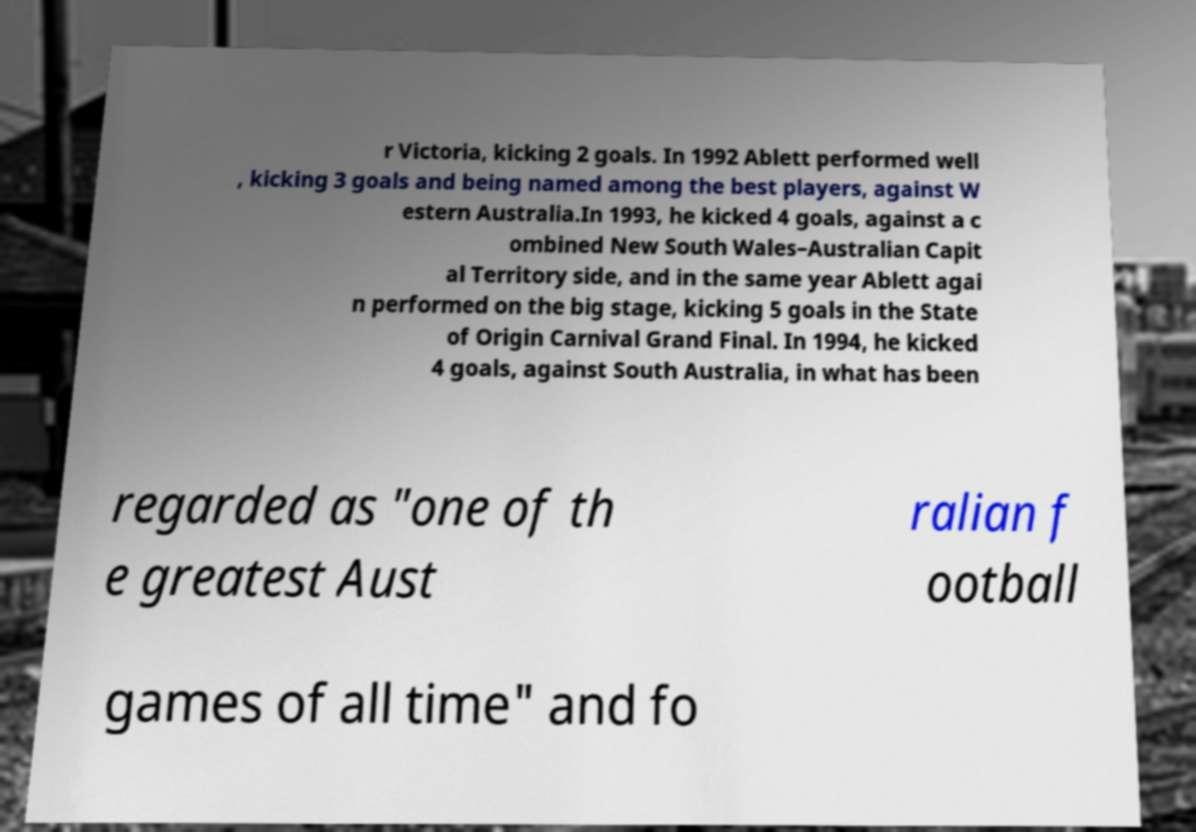Could you extract and type out the text from this image? r Victoria, kicking 2 goals. In 1992 Ablett performed well , kicking 3 goals and being named among the best players, against W estern Australia.In 1993, he kicked 4 goals, against a c ombined New South Wales–Australian Capit al Territory side, and in the same year Ablett agai n performed on the big stage, kicking 5 goals in the State of Origin Carnival Grand Final. In 1994, he kicked 4 goals, against South Australia, in what has been regarded as "one of th e greatest Aust ralian f ootball games of all time" and fo 